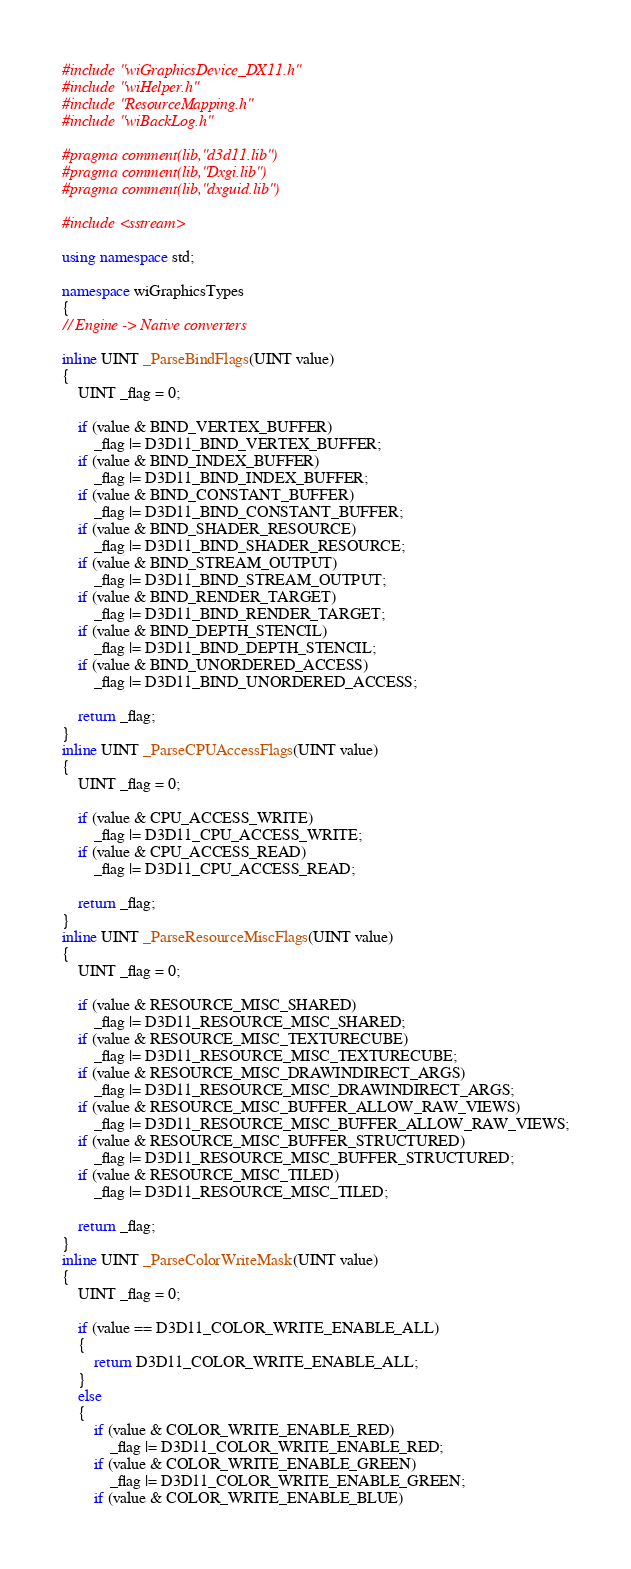Convert code to text. <code><loc_0><loc_0><loc_500><loc_500><_C++_>#include "wiGraphicsDevice_DX11.h"
#include "wiHelper.h"
#include "ResourceMapping.h"
#include "wiBackLog.h"

#pragma comment(lib,"d3d11.lib")
#pragma comment(lib,"Dxgi.lib")
#pragma comment(lib,"dxguid.lib")

#include <sstream>

using namespace std;

namespace wiGraphicsTypes
{
// Engine -> Native converters

inline UINT _ParseBindFlags(UINT value)
{
	UINT _flag = 0;

	if (value & BIND_VERTEX_BUFFER)
		_flag |= D3D11_BIND_VERTEX_BUFFER;
	if (value & BIND_INDEX_BUFFER)
		_flag |= D3D11_BIND_INDEX_BUFFER;
	if (value & BIND_CONSTANT_BUFFER)
		_flag |= D3D11_BIND_CONSTANT_BUFFER;
	if (value & BIND_SHADER_RESOURCE)
		_flag |= D3D11_BIND_SHADER_RESOURCE;
	if (value & BIND_STREAM_OUTPUT)
		_flag |= D3D11_BIND_STREAM_OUTPUT;
	if (value & BIND_RENDER_TARGET)
		_flag |= D3D11_BIND_RENDER_TARGET;
	if (value & BIND_DEPTH_STENCIL)
		_flag |= D3D11_BIND_DEPTH_STENCIL;
	if (value & BIND_UNORDERED_ACCESS)
		_flag |= D3D11_BIND_UNORDERED_ACCESS;

	return _flag;
}
inline UINT _ParseCPUAccessFlags(UINT value)
{
	UINT _flag = 0;

	if (value & CPU_ACCESS_WRITE)
		_flag |= D3D11_CPU_ACCESS_WRITE;
	if (value & CPU_ACCESS_READ)
		_flag |= D3D11_CPU_ACCESS_READ;

	return _flag;
}
inline UINT _ParseResourceMiscFlags(UINT value)
{
	UINT _flag = 0;

	if (value & RESOURCE_MISC_SHARED)
		_flag |= D3D11_RESOURCE_MISC_SHARED;
	if (value & RESOURCE_MISC_TEXTURECUBE)
		_flag |= D3D11_RESOURCE_MISC_TEXTURECUBE;
	if (value & RESOURCE_MISC_DRAWINDIRECT_ARGS)
		_flag |= D3D11_RESOURCE_MISC_DRAWINDIRECT_ARGS;
	if (value & RESOURCE_MISC_BUFFER_ALLOW_RAW_VIEWS)
		_flag |= D3D11_RESOURCE_MISC_BUFFER_ALLOW_RAW_VIEWS;
	if (value & RESOURCE_MISC_BUFFER_STRUCTURED)
		_flag |= D3D11_RESOURCE_MISC_BUFFER_STRUCTURED;
	if (value & RESOURCE_MISC_TILED)
		_flag |= D3D11_RESOURCE_MISC_TILED;

	return _flag;
}
inline UINT _ParseColorWriteMask(UINT value)
{
	UINT _flag = 0;

	if (value == D3D11_COLOR_WRITE_ENABLE_ALL)
	{
		return D3D11_COLOR_WRITE_ENABLE_ALL;
	}
	else
	{
		if (value & COLOR_WRITE_ENABLE_RED)
			_flag |= D3D11_COLOR_WRITE_ENABLE_RED;
		if (value & COLOR_WRITE_ENABLE_GREEN)
			_flag |= D3D11_COLOR_WRITE_ENABLE_GREEN;
		if (value & COLOR_WRITE_ENABLE_BLUE)</code> 